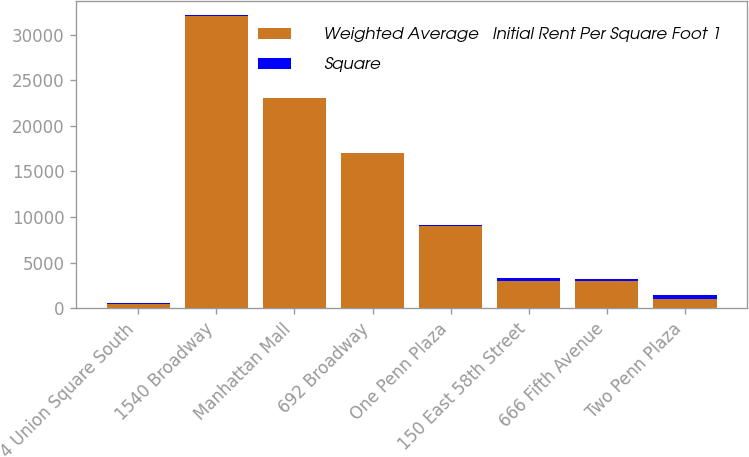Convert chart to OTSL. <chart><loc_0><loc_0><loc_500><loc_500><stacked_bar_chart><ecel><fcel>4 Union Square South<fcel>1540 Broadway<fcel>Manhattan Mall<fcel>692 Broadway<fcel>One Penn Plaza<fcel>150 East 58th Street<fcel>666 Fifth Avenue<fcel>Two Penn Plaza<nl><fcel>Weighted Average   Initial Rent Per Square Foot 1<fcel>479<fcel>32000<fcel>23000<fcel>17000<fcel>9000<fcel>3000<fcel>3000<fcel>1000<nl><fcel>Square<fcel>65.33<fcel>93.31<fcel>94.53<fcel>58.58<fcel>150.73<fcel>337.74<fcel>170.66<fcel>479<nl></chart> 